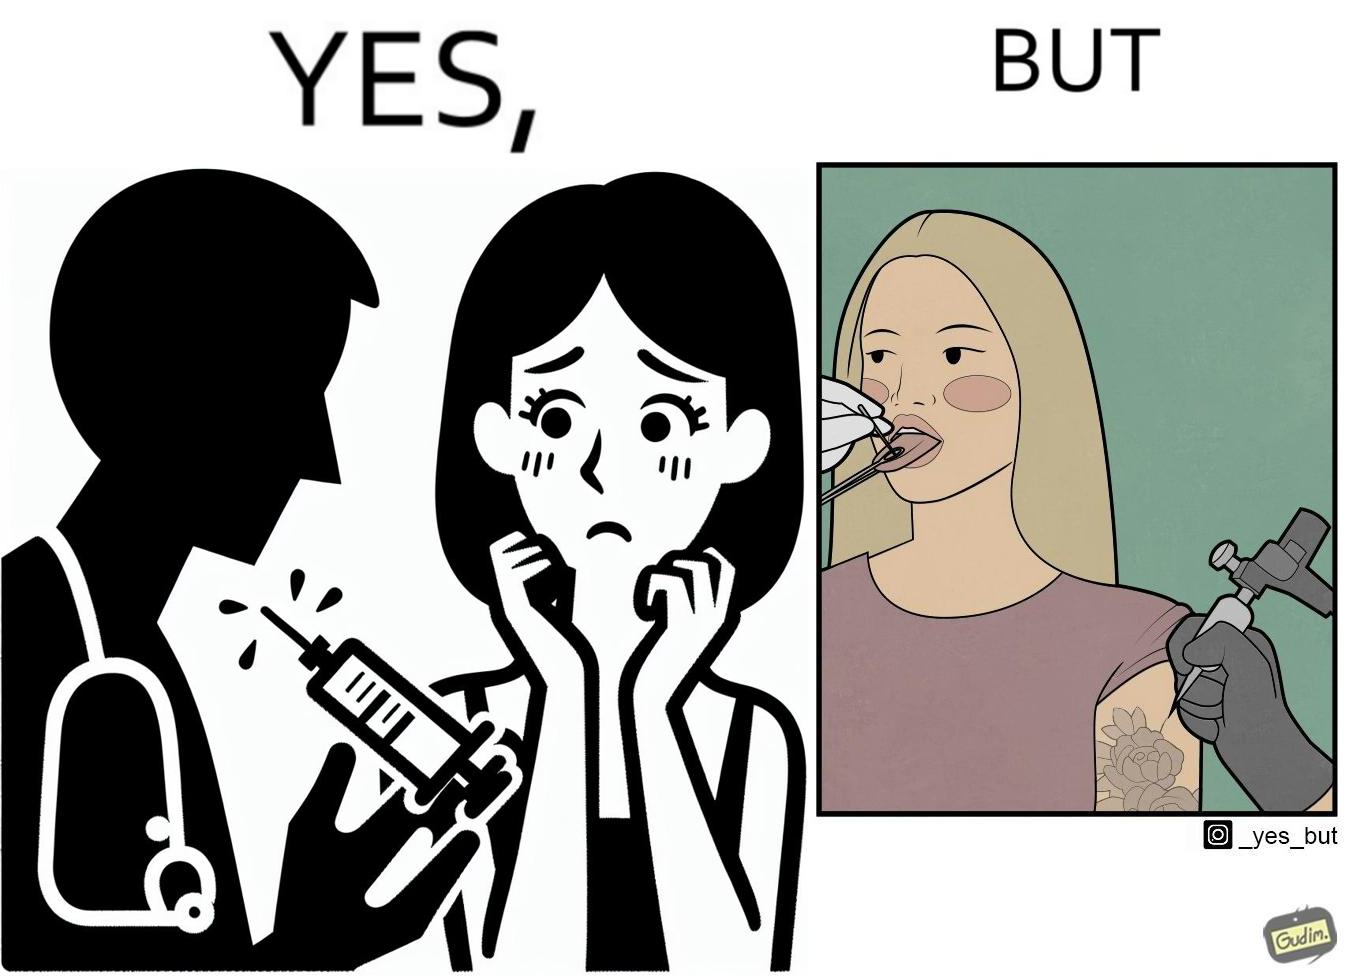Does this image contain satire or humor? Yes, this image is satirical. 